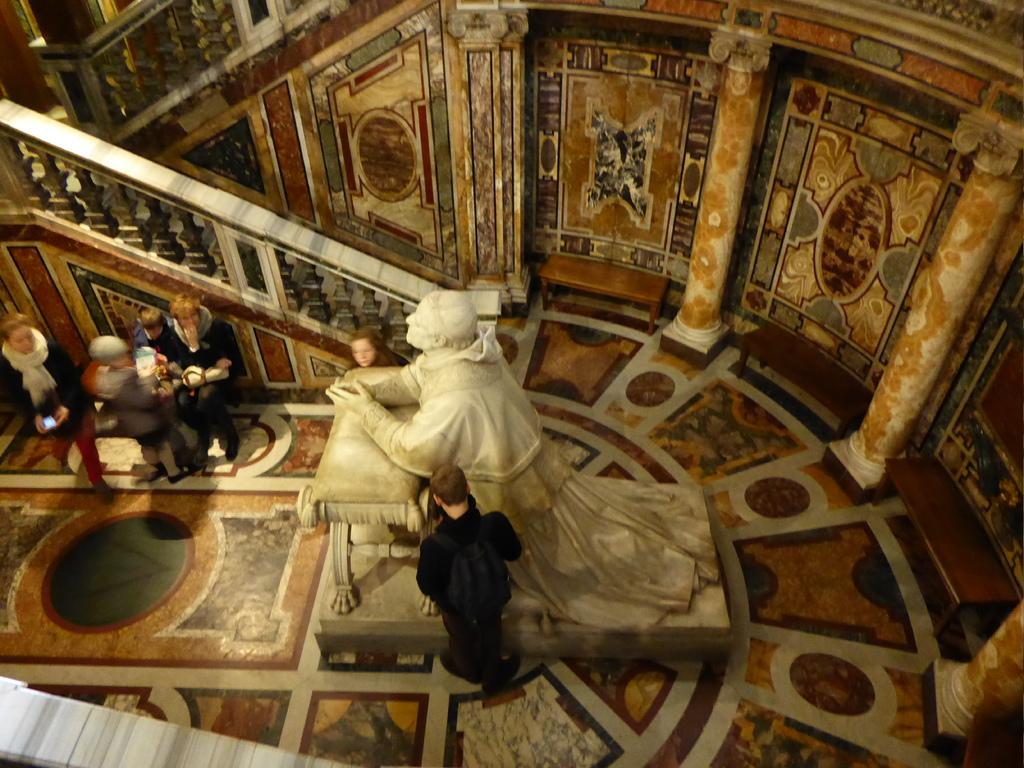What type of flooring is visible in the image? There are tiles in the image. Can you describe the people in the image? There are people in the image, but their specific actions or characteristics are not mentioned in the facts. What is the statue made of in the image? The statue is white in color in the image. What is the background of the image composed of? There is a wall and a fence in the image. How many quinces are hanging from the fence in the image? There are no quinces present in the image; it features tiles, people, a white color statue, a wall, and a fence. Can you describe the behavior of the hen in the image? There is no hen present in the image. 